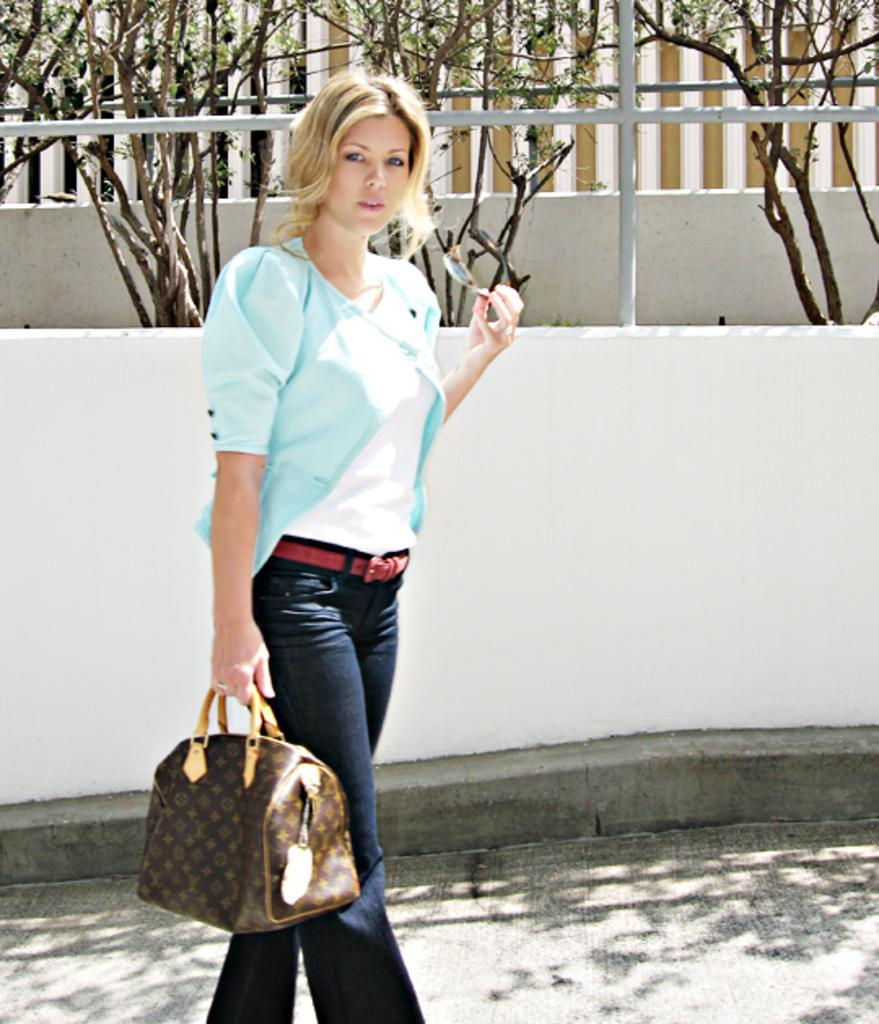What is the main subject of the image? There is a woman in the image. What is the woman doing in the image? The woman is standing in the image. What is the woman holding in her right hand? The woman is holding a bag with her right hand. What is the woman holding in her left hand? The woman is holding spectacles with her left hand. What can be seen in the background of the image? There is a tree and a building in the background of the image. How many pizzas are being delivered in the image? There are no pizzas or delivery mentioned in the image; it features a woman standing with a bag and spectacles. What type of spark can be seen coming from the woman's spectacles in the image? There is no spark visible in the image; the woman is simply holding spectacles. 